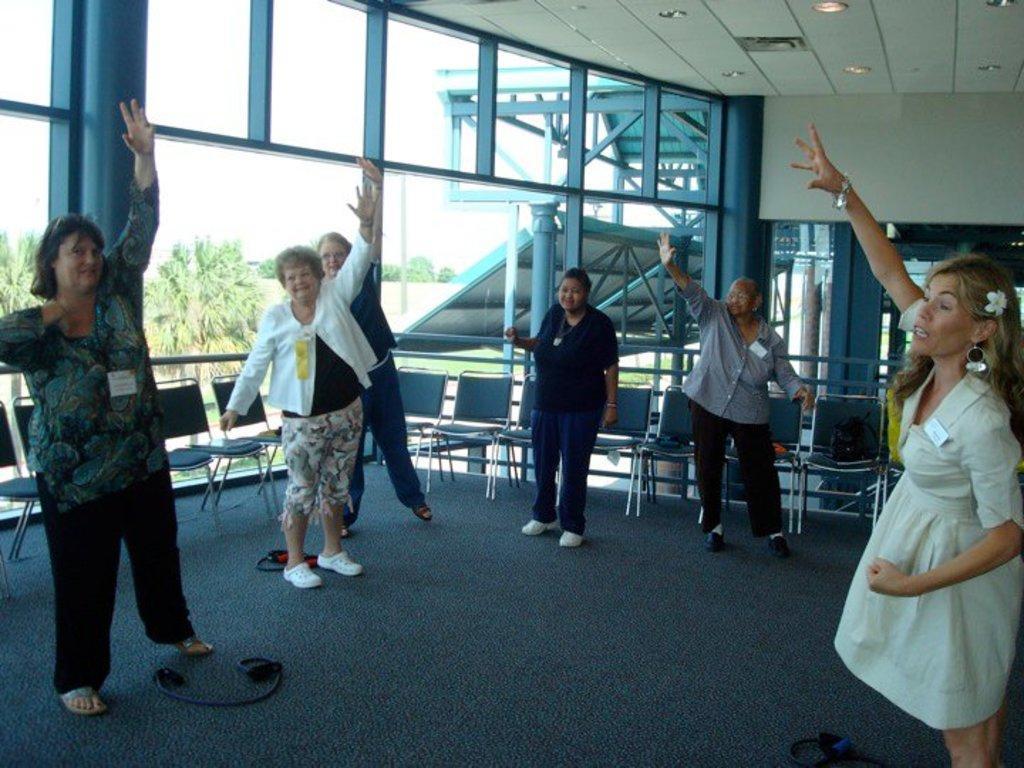Describe this image in one or two sentences. In the foreground of this picture, there are persons standing on the floor raising their hand up in the air. In the background, we can see chairs, glass wall, ceiling and the lights and we can also see few trees through the glass. 